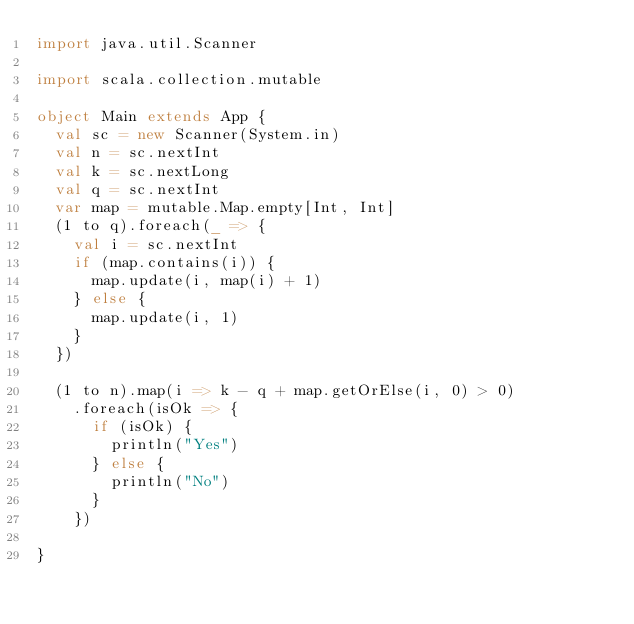<code> <loc_0><loc_0><loc_500><loc_500><_Scala_>import java.util.Scanner

import scala.collection.mutable

object Main extends App {
  val sc = new Scanner(System.in)
  val n = sc.nextInt
  val k = sc.nextLong
  val q = sc.nextInt
  var map = mutable.Map.empty[Int, Int]
  (1 to q).foreach(_ => {
    val i = sc.nextInt
    if (map.contains(i)) {
      map.update(i, map(i) + 1)
    } else {
      map.update(i, 1)
    }
  })

  (1 to n).map(i => k - q + map.getOrElse(i, 0) > 0)
    .foreach(isOk => {
      if (isOk) {
        println("Yes")
      } else {
        println("No")
      }
    })

}
</code> 